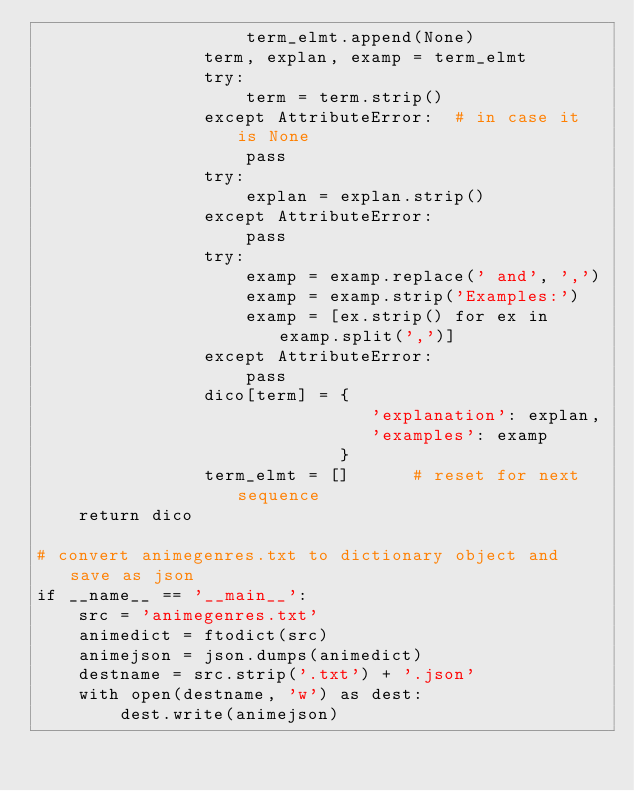Convert code to text. <code><loc_0><loc_0><loc_500><loc_500><_Python_>                    term_elmt.append(None)
                term, explan, examp = term_elmt
                try:
                    term = term.strip()
                except AttributeError:  # in case it is None
                    pass
                try:
                    explan = explan.strip()
                except AttributeError:
                    pass
                try:
                    examp = examp.replace(' and', ',')
                    examp = examp.strip('Examples:')
                    examp = [ex.strip() for ex in examp.split(',')]
                except AttributeError:
                    pass
                dico[term] = {
                                'explanation': explan,
                                'examples': examp
                             }
                term_elmt = []      # reset for next sequence
    return dico

# convert animegenres.txt to dictionary object and save as json
if __name__ == '__main__':
    src = 'animegenres.txt'
    animedict = ftodict(src)
    animejson = json.dumps(animedict)
    destname = src.strip('.txt') + '.json'
    with open(destname, 'w') as dest:
        dest.write(animejson)
</code> 